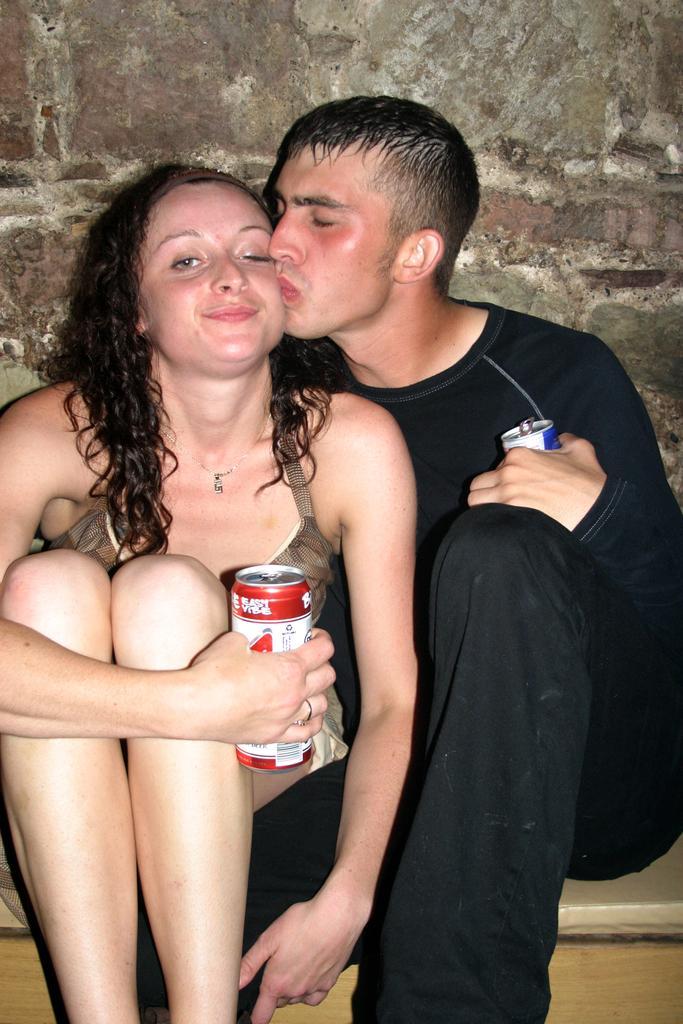Describe this image in one or two sentences. In the center of the image we can see two persons are sitting on some object. And we can see they are holding cans. And the right side person is kissing the other person. In the background there is a wall. 